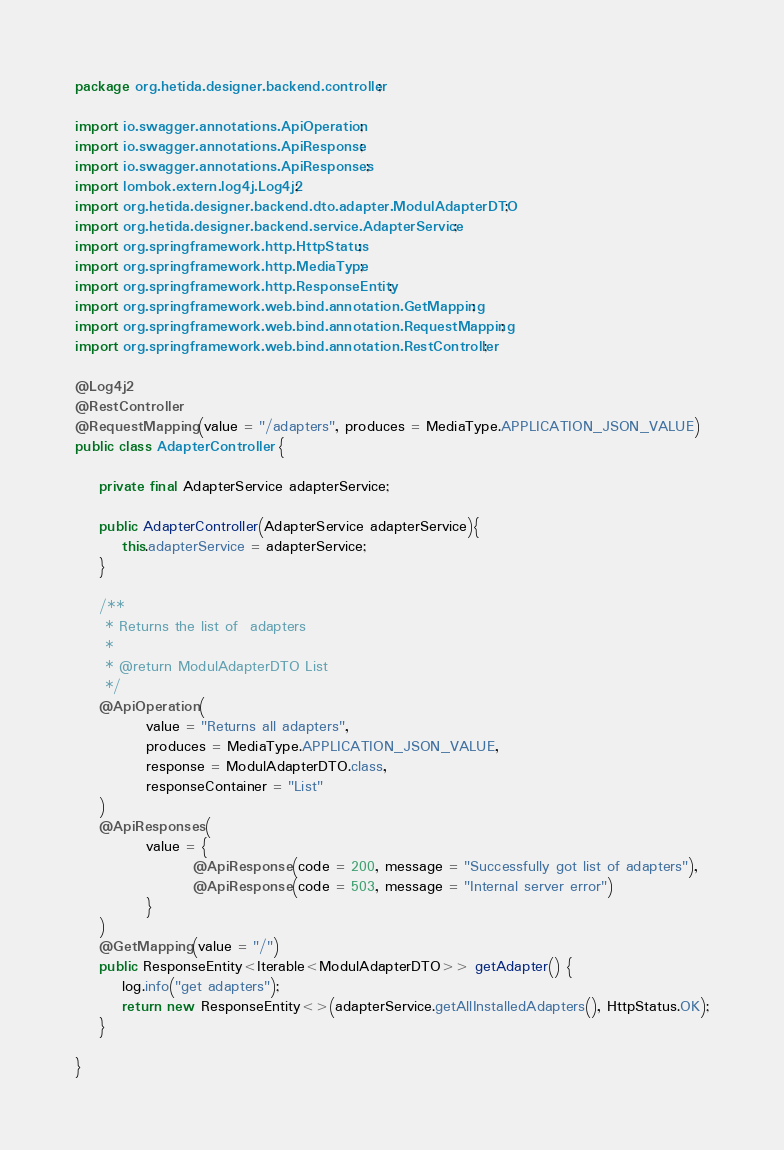<code> <loc_0><loc_0><loc_500><loc_500><_Java_>package org.hetida.designer.backend.controller;

import io.swagger.annotations.ApiOperation;
import io.swagger.annotations.ApiResponse;
import io.swagger.annotations.ApiResponses;
import lombok.extern.log4j.Log4j2;
import org.hetida.designer.backend.dto.adapter.ModulAdapterDTO;
import org.hetida.designer.backend.service.AdapterService;
import org.springframework.http.HttpStatus;
import org.springframework.http.MediaType;
import org.springframework.http.ResponseEntity;
import org.springframework.web.bind.annotation.GetMapping;
import org.springframework.web.bind.annotation.RequestMapping;
import org.springframework.web.bind.annotation.RestController;

@Log4j2
@RestController
@RequestMapping(value = "/adapters", produces = MediaType.APPLICATION_JSON_VALUE)
public class AdapterController {

    private final AdapterService adapterService;

    public AdapterController(AdapterService adapterService){
        this.adapterService = adapterService;
    }

    /**
     * Returns the list of  adapters
     *
     * @return ModulAdapterDTO List
     */
    @ApiOperation(
            value = "Returns all adapters",
            produces = MediaType.APPLICATION_JSON_VALUE,
            response = ModulAdapterDTO.class,
            responseContainer = "List"
    )
    @ApiResponses(
            value = {
                    @ApiResponse(code = 200, message = "Successfully got list of adapters"),
                    @ApiResponse(code = 503, message = "Internal server error")
            }
    )
    @GetMapping(value = "/")
    public ResponseEntity<Iterable<ModulAdapterDTO>> getAdapter() {
        log.info("get adapters");
        return new ResponseEntity<>(adapterService.getAllInstalledAdapters(), HttpStatus.OK);
    }

}
</code> 